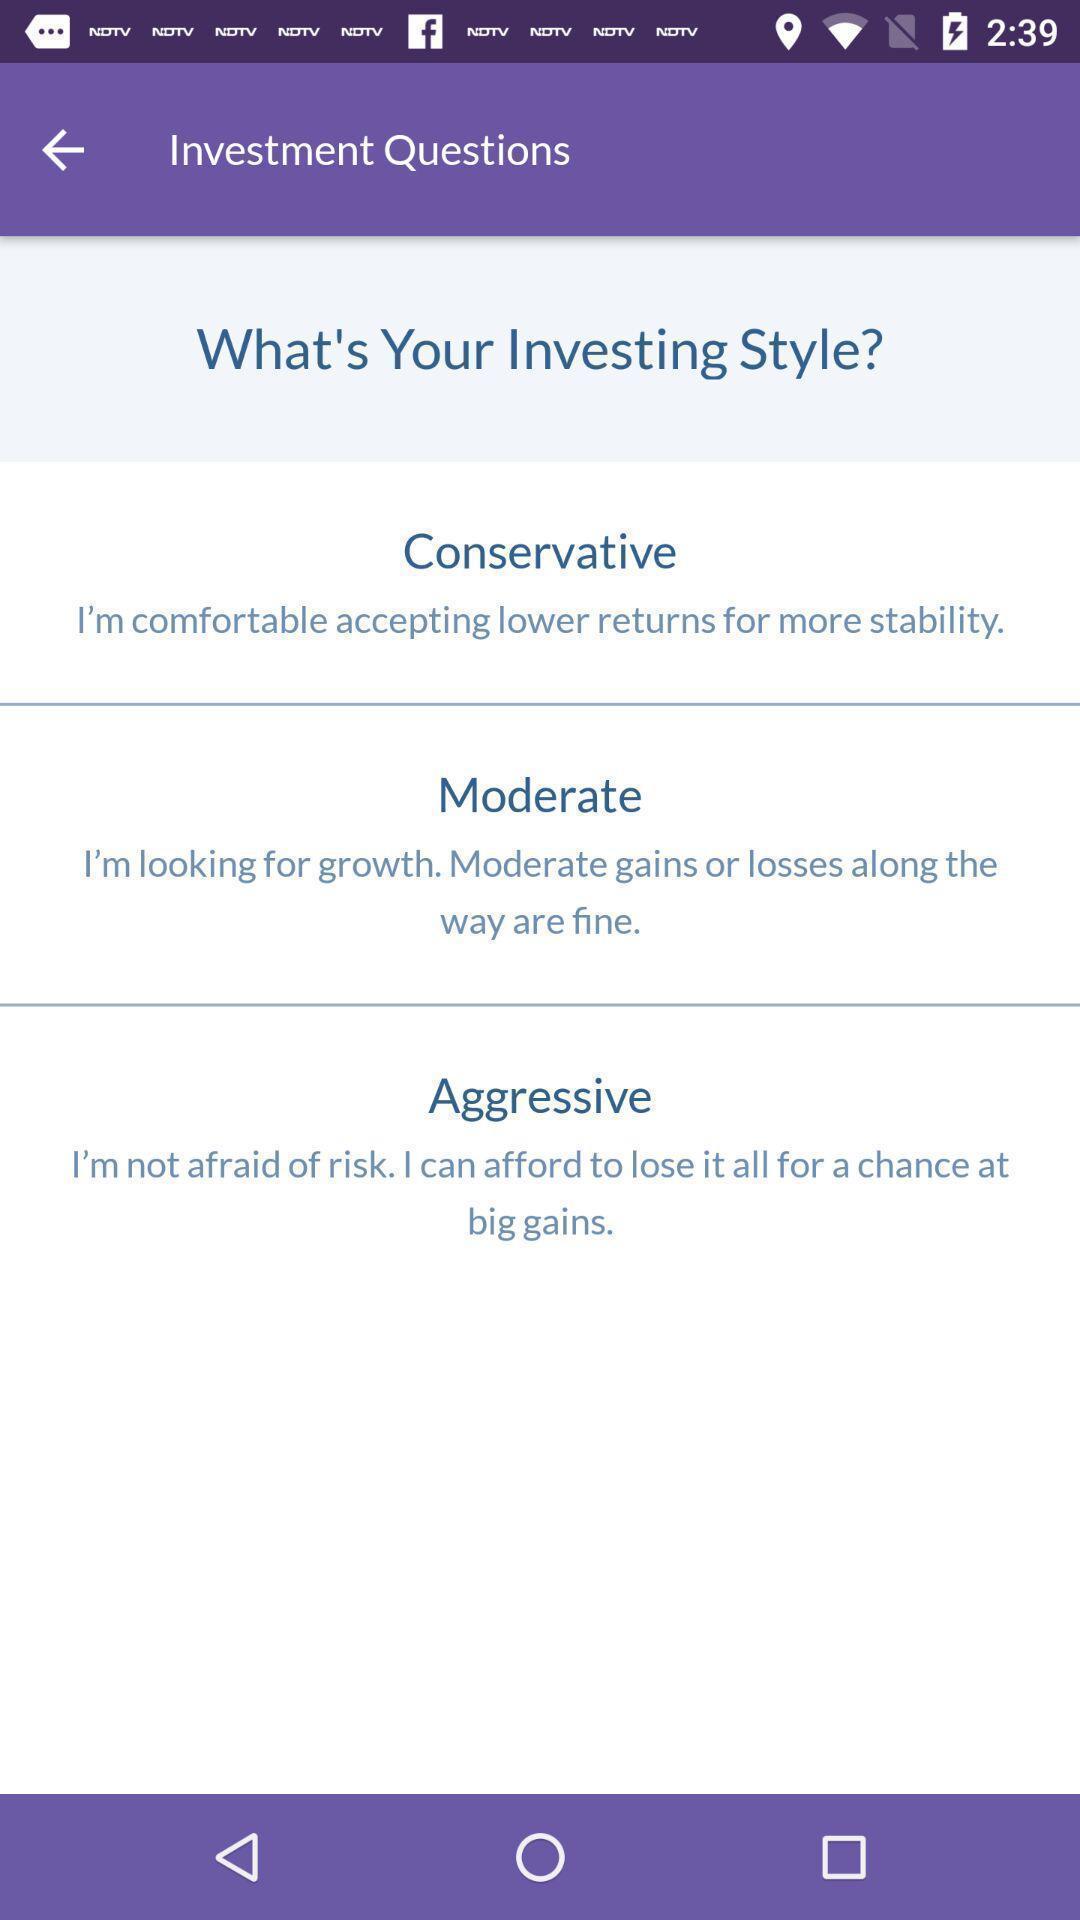What is the overall content of this screenshot? Screen shows investment questions. 